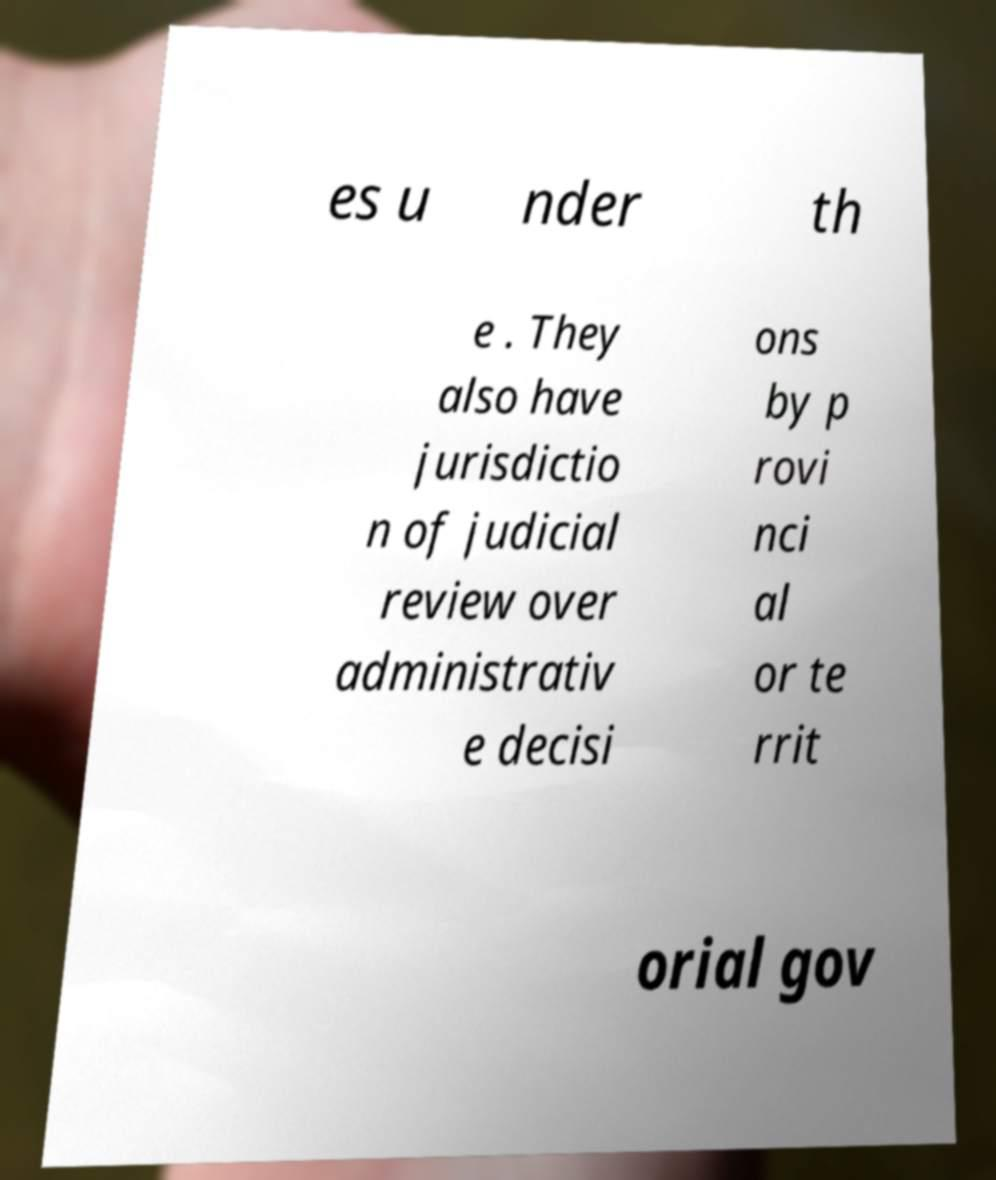There's text embedded in this image that I need extracted. Can you transcribe it verbatim? es u nder th e . They also have jurisdictio n of judicial review over administrativ e decisi ons by p rovi nci al or te rrit orial gov 